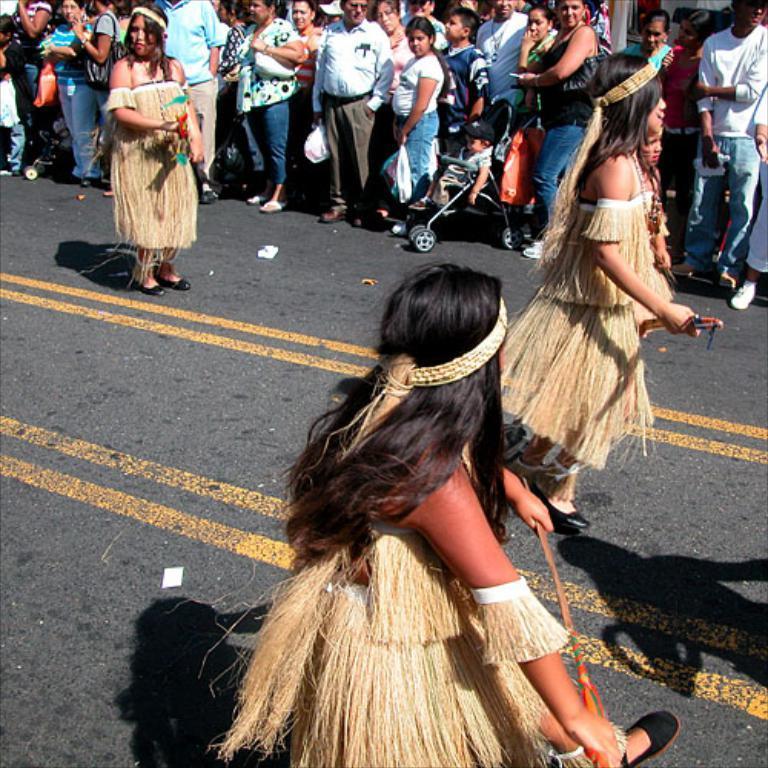Describe this image in one or two sentences. As we can see in the image there are lot of people gathered and they are watching the three women who are dancing on the road. 